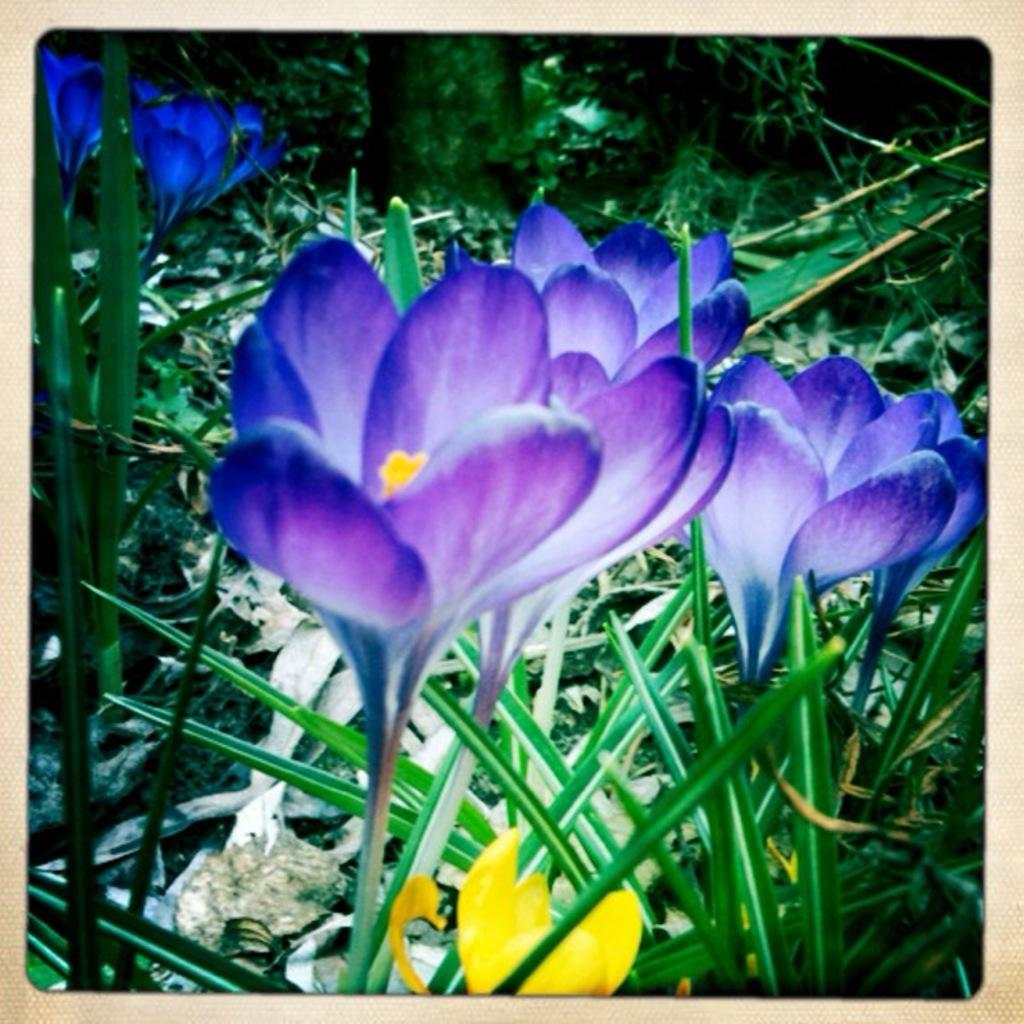What color are the flowers on some of the plants in the image? The flowers on some of the plants in the image are violet and yellow. Can you describe the plants in the background of the image? There are plants in the background of the image, but their specific characteristics are not mentioned in the provided facts. What type of vegetation is visible in the background of the image? In addition to plants, there are trees visible in the background of the image. How many times does the person in the image sneeze while looking at the plants? There is no person present in the image, so it is not possible to determine how many times they might sneeze. 